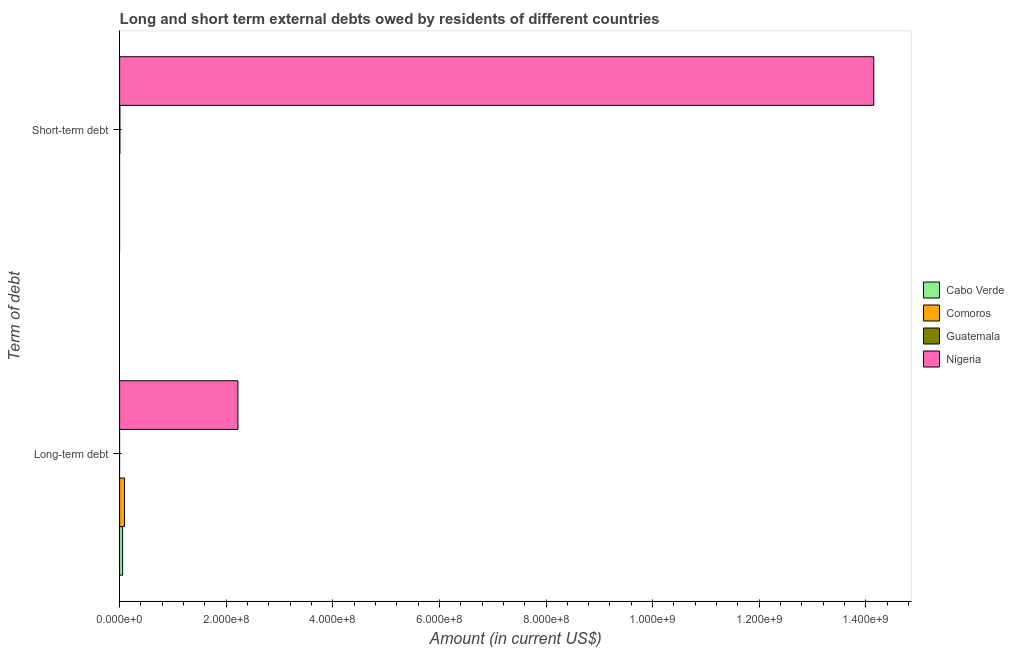How many different coloured bars are there?
Give a very brief answer. 4. How many groups of bars are there?
Make the answer very short. 2. What is the label of the 2nd group of bars from the top?
Your answer should be very brief. Long-term debt. What is the long-term debts owed by residents in Nigeria?
Keep it short and to the point. 2.22e+08. Across all countries, what is the maximum long-term debts owed by residents?
Offer a very short reply. 2.22e+08. Across all countries, what is the minimum short-term debts owed by residents?
Make the answer very short. 0. In which country was the short-term debts owed by residents maximum?
Provide a succinct answer. Nigeria. What is the total short-term debts owed by residents in the graph?
Offer a terse response. 1.42e+09. What is the difference between the long-term debts owed by residents in Comoros and that in Nigeria?
Offer a terse response. -2.13e+08. What is the difference between the long-term debts owed by residents in Comoros and the short-term debts owed by residents in Cabo Verde?
Give a very brief answer. 9.28e+06. What is the average short-term debts owed by residents per country?
Make the answer very short. 3.54e+08. What is the difference between the long-term debts owed by residents and short-term debts owed by residents in Nigeria?
Your response must be concise. -1.19e+09. In how many countries, is the long-term debts owed by residents greater than 1360000000 US$?
Make the answer very short. 0. How many countries are there in the graph?
Give a very brief answer. 4. What is the difference between two consecutive major ticks on the X-axis?
Your answer should be compact. 2.00e+08. Are the values on the major ticks of X-axis written in scientific E-notation?
Provide a short and direct response. Yes. Does the graph contain any zero values?
Keep it short and to the point. Yes. Where does the legend appear in the graph?
Your answer should be compact. Center right. What is the title of the graph?
Offer a terse response. Long and short term external debts owed by residents of different countries. What is the label or title of the Y-axis?
Your response must be concise. Term of debt. What is the Amount (in current US$) in Cabo Verde in Long-term debt?
Provide a succinct answer. 5.61e+06. What is the Amount (in current US$) of Comoros in Long-term debt?
Offer a very short reply. 9.28e+06. What is the Amount (in current US$) of Nigeria in Long-term debt?
Make the answer very short. 2.22e+08. What is the Amount (in current US$) in Cabo Verde in Short-term debt?
Provide a short and direct response. 0. What is the Amount (in current US$) of Guatemala in Short-term debt?
Provide a short and direct response. 5.02e+05. What is the Amount (in current US$) in Nigeria in Short-term debt?
Your answer should be very brief. 1.41e+09. Across all Term of debt, what is the maximum Amount (in current US$) of Cabo Verde?
Make the answer very short. 5.61e+06. Across all Term of debt, what is the maximum Amount (in current US$) in Comoros?
Provide a short and direct response. 9.28e+06. Across all Term of debt, what is the maximum Amount (in current US$) in Guatemala?
Provide a short and direct response. 5.02e+05. Across all Term of debt, what is the maximum Amount (in current US$) of Nigeria?
Your response must be concise. 1.41e+09. Across all Term of debt, what is the minimum Amount (in current US$) in Cabo Verde?
Your response must be concise. 0. Across all Term of debt, what is the minimum Amount (in current US$) of Nigeria?
Your answer should be very brief. 2.22e+08. What is the total Amount (in current US$) of Cabo Verde in the graph?
Give a very brief answer. 5.61e+06. What is the total Amount (in current US$) of Comoros in the graph?
Your answer should be compact. 9.28e+06. What is the total Amount (in current US$) of Guatemala in the graph?
Your answer should be very brief. 5.02e+05. What is the total Amount (in current US$) in Nigeria in the graph?
Your answer should be very brief. 1.64e+09. What is the difference between the Amount (in current US$) in Nigeria in Long-term debt and that in Short-term debt?
Your answer should be very brief. -1.19e+09. What is the difference between the Amount (in current US$) in Cabo Verde in Long-term debt and the Amount (in current US$) in Guatemala in Short-term debt?
Provide a short and direct response. 5.11e+06. What is the difference between the Amount (in current US$) of Cabo Verde in Long-term debt and the Amount (in current US$) of Nigeria in Short-term debt?
Offer a terse response. -1.41e+09. What is the difference between the Amount (in current US$) in Comoros in Long-term debt and the Amount (in current US$) in Guatemala in Short-term debt?
Give a very brief answer. 8.78e+06. What is the difference between the Amount (in current US$) in Comoros in Long-term debt and the Amount (in current US$) in Nigeria in Short-term debt?
Give a very brief answer. -1.41e+09. What is the average Amount (in current US$) of Cabo Verde per Term of debt?
Give a very brief answer. 2.81e+06. What is the average Amount (in current US$) in Comoros per Term of debt?
Make the answer very short. 4.64e+06. What is the average Amount (in current US$) in Guatemala per Term of debt?
Provide a short and direct response. 2.51e+05. What is the average Amount (in current US$) of Nigeria per Term of debt?
Provide a succinct answer. 8.18e+08. What is the difference between the Amount (in current US$) in Cabo Verde and Amount (in current US$) in Comoros in Long-term debt?
Offer a very short reply. -3.67e+06. What is the difference between the Amount (in current US$) of Cabo Verde and Amount (in current US$) of Nigeria in Long-term debt?
Give a very brief answer. -2.16e+08. What is the difference between the Amount (in current US$) in Comoros and Amount (in current US$) in Nigeria in Long-term debt?
Your answer should be compact. -2.13e+08. What is the difference between the Amount (in current US$) in Guatemala and Amount (in current US$) in Nigeria in Short-term debt?
Provide a succinct answer. -1.41e+09. What is the ratio of the Amount (in current US$) in Nigeria in Long-term debt to that in Short-term debt?
Your response must be concise. 0.16. What is the difference between the highest and the second highest Amount (in current US$) in Nigeria?
Offer a very short reply. 1.19e+09. What is the difference between the highest and the lowest Amount (in current US$) of Cabo Verde?
Give a very brief answer. 5.61e+06. What is the difference between the highest and the lowest Amount (in current US$) in Comoros?
Your response must be concise. 9.28e+06. What is the difference between the highest and the lowest Amount (in current US$) in Guatemala?
Your response must be concise. 5.02e+05. What is the difference between the highest and the lowest Amount (in current US$) in Nigeria?
Offer a terse response. 1.19e+09. 